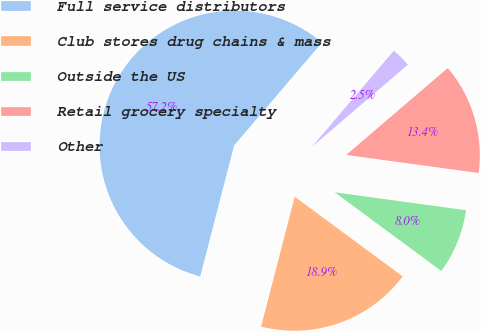Convert chart. <chart><loc_0><loc_0><loc_500><loc_500><pie_chart><fcel>Full service distributors<fcel>Club stores drug chains & mass<fcel>Outside the US<fcel>Retail grocery specialty<fcel>Other<nl><fcel>57.21%<fcel>18.91%<fcel>7.96%<fcel>13.43%<fcel>2.49%<nl></chart> 